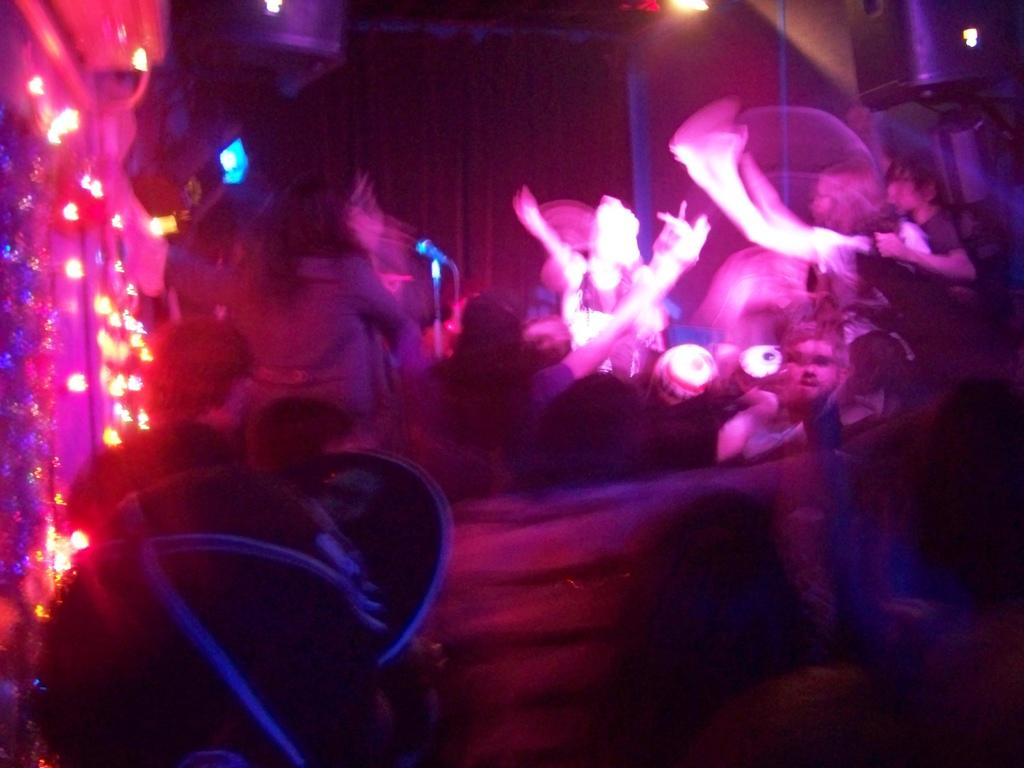What can be seen in the image that provides illumination? There are lights in the image that provide illumination. Who or what is present in the image? There are people in the image. What object is used for amplifying sound in the image? There is a microphone on a stand in the image. Can you describe any other objects in the image besides the lights, people, and microphone? There are other unspecified objects in the image. What type of finger can be seen in the image? There is no finger present in the image. Can you describe the sound of the thunder in the image? There is no thunder present in the image; it is a silent scene. 